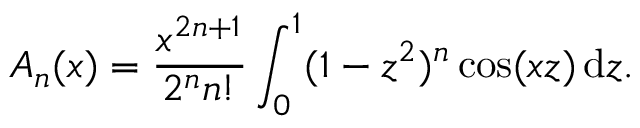<formula> <loc_0><loc_0><loc_500><loc_500>A _ { n } ( x ) = { \frac { x ^ { 2 n + 1 } } { 2 ^ { n } n ! } } \int _ { 0 } ^ { 1 } ( 1 - z ^ { 2 } ) ^ { n } \cos ( x z ) \, d z .</formula> 